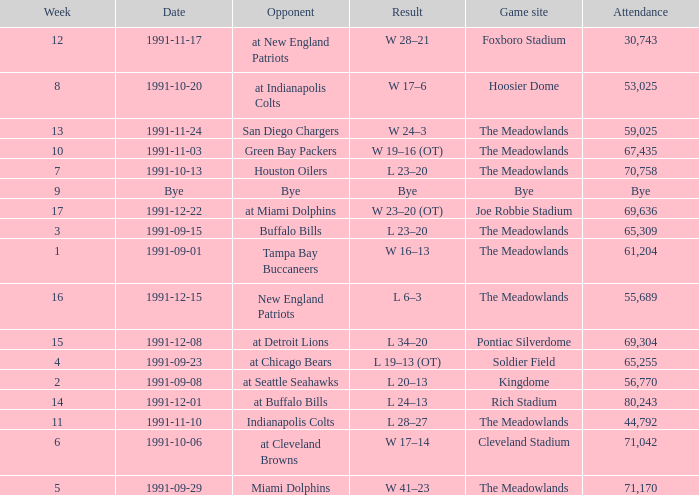Which Opponent was played on 1991-10-13? Houston Oilers. 